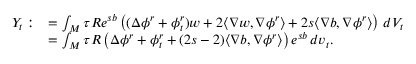Convert formula to latex. <formula><loc_0><loc_0><loc_500><loc_500>\begin{array} { r l } { Y _ { t } \colon } & { = \int _ { M } \tau R e ^ { s b } \left ( ( \Delta \phi ^ { r } + \phi _ { t } ^ { r } ) w + 2 \langle \nabla w , \nabla \phi ^ { r } \rangle + 2 s \langle \nabla b , \nabla \phi ^ { r } \rangle \right ) \, d V _ { t } } \\ & { = \int _ { M } \tau R \left ( \Delta \phi ^ { r } + \phi _ { t } ^ { r } + ( 2 s - 2 ) \langle \nabla b , \nabla \phi ^ { r } \rangle \right ) e ^ { s b } \, d v _ { t } . } \end{array}</formula> 